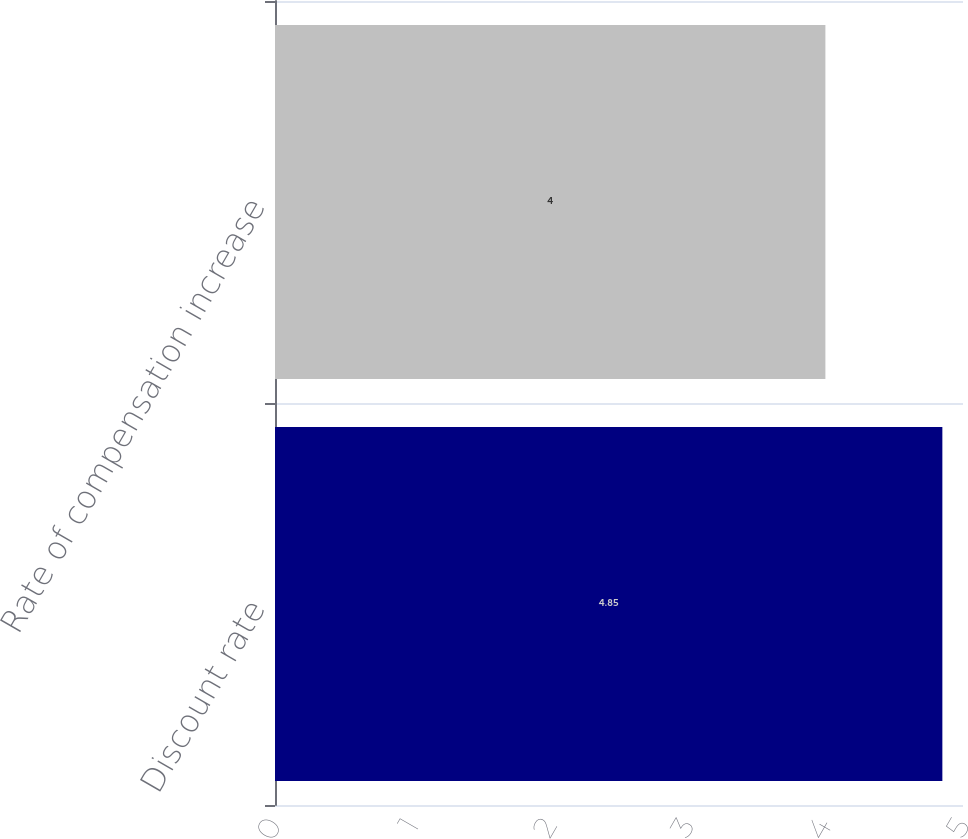<chart> <loc_0><loc_0><loc_500><loc_500><bar_chart><fcel>Discount rate<fcel>Rate of compensation increase<nl><fcel>4.85<fcel>4<nl></chart> 